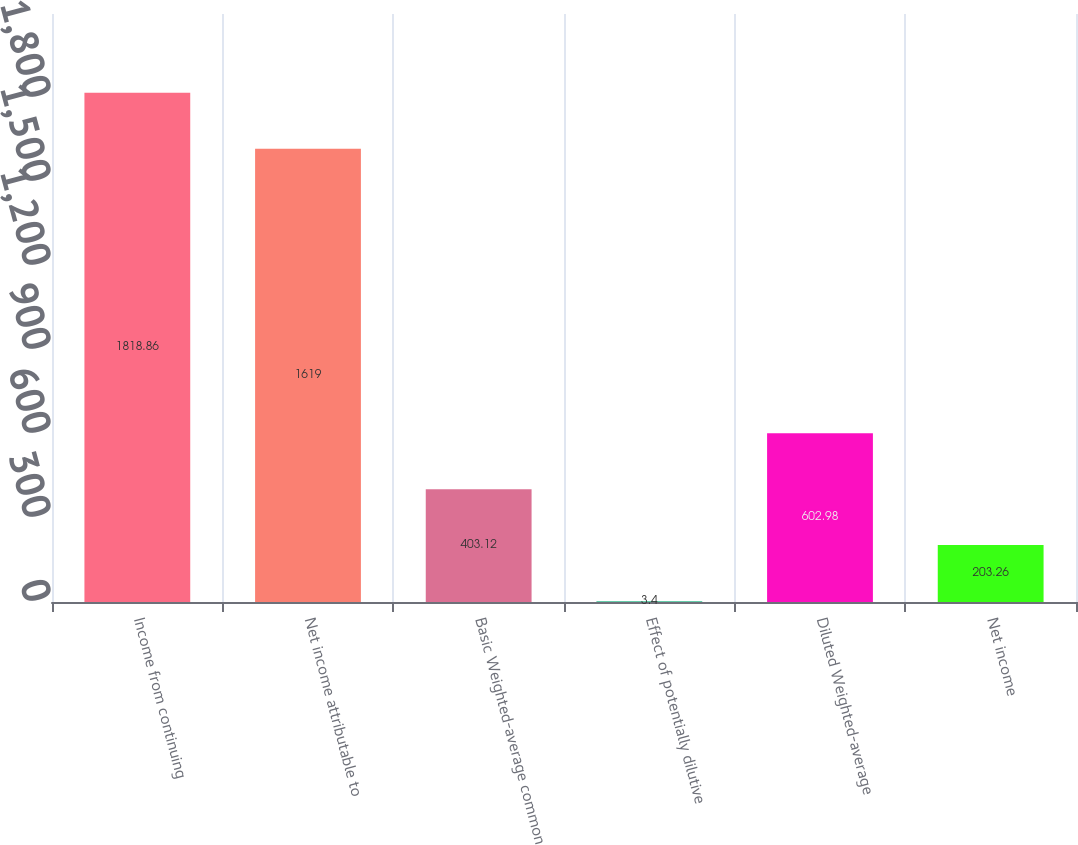Convert chart to OTSL. <chart><loc_0><loc_0><loc_500><loc_500><bar_chart><fcel>Income from continuing<fcel>Net income attributable to<fcel>Basic Weighted-average common<fcel>Effect of potentially dilutive<fcel>Diluted Weighted-average<fcel>Net income<nl><fcel>1818.86<fcel>1619<fcel>403.12<fcel>3.4<fcel>602.98<fcel>203.26<nl></chart> 